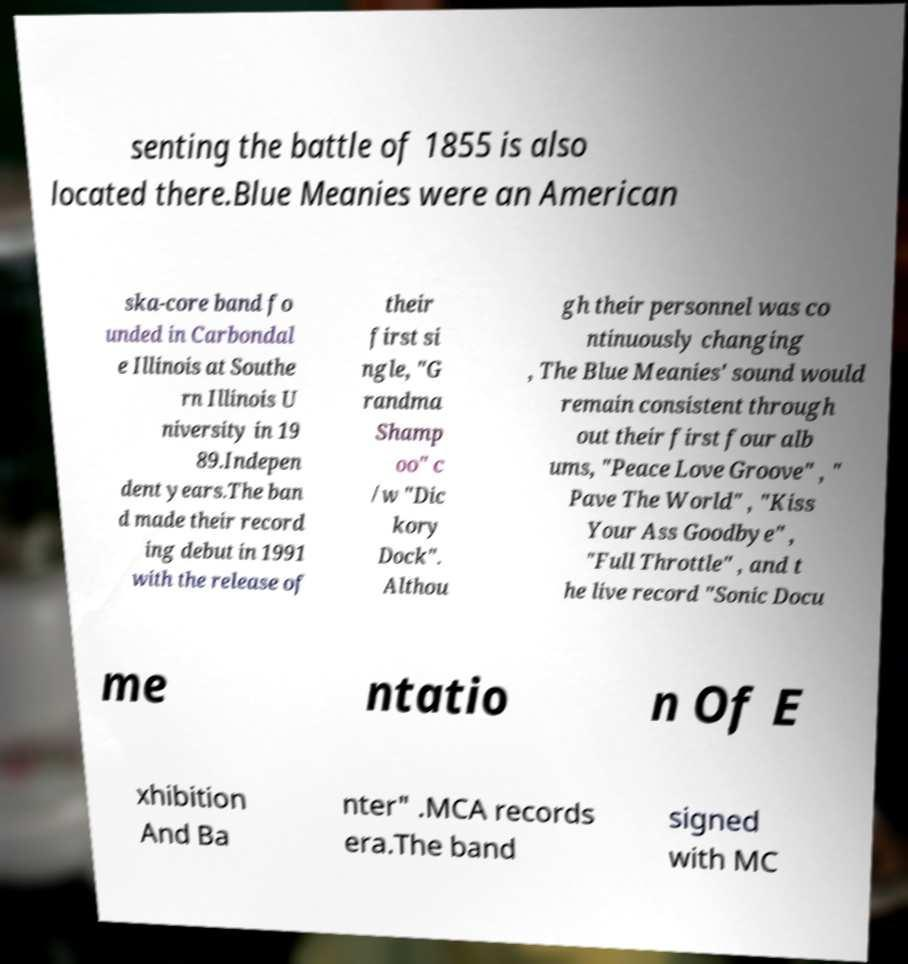Can you accurately transcribe the text from the provided image for me? senting the battle of 1855 is also located there.Blue Meanies were an American ska-core band fo unded in Carbondal e Illinois at Southe rn Illinois U niversity in 19 89.Indepen dent years.The ban d made their record ing debut in 1991 with the release of their first si ngle, "G randma Shamp oo" c /w "Dic kory Dock". Althou gh their personnel was co ntinuously changing , The Blue Meanies' sound would remain consistent through out their first four alb ums, "Peace Love Groove" , " Pave The World" , "Kiss Your Ass Goodbye" , "Full Throttle" , and t he live record "Sonic Docu me ntatio n Of E xhibition And Ba nter" .MCA records era.The band signed with MC 